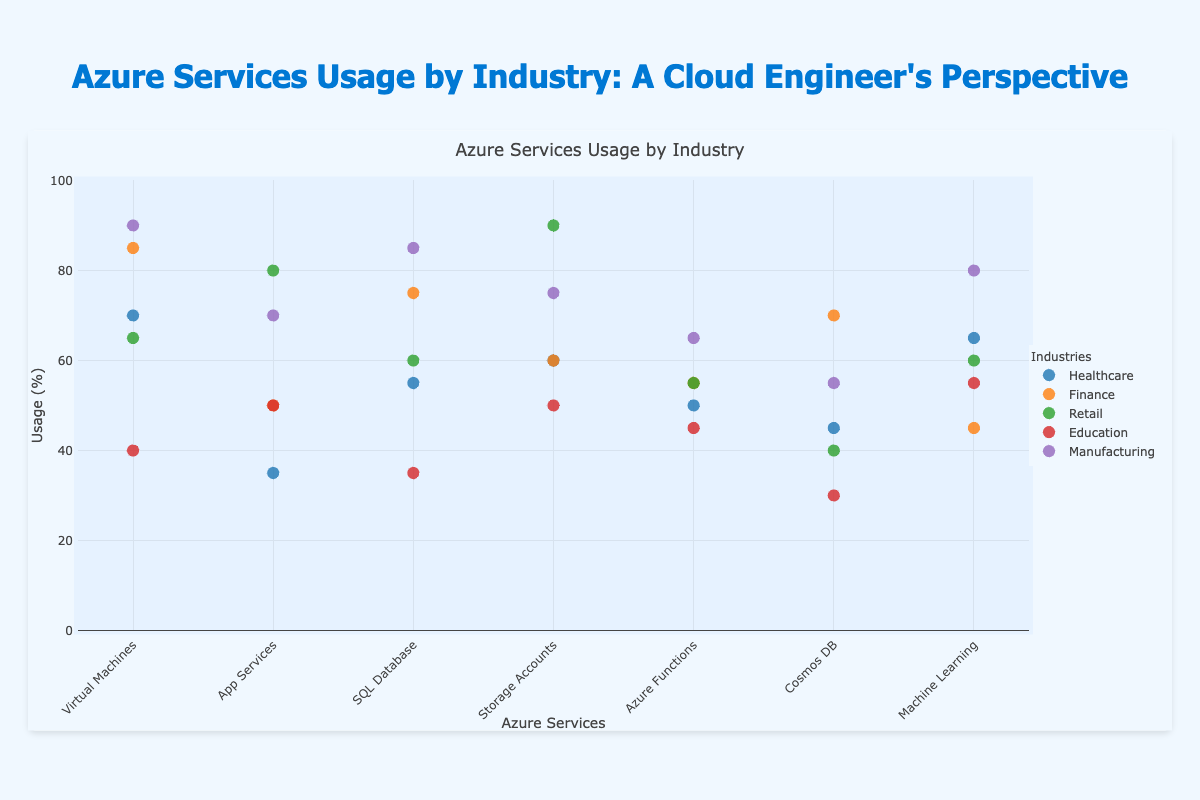How many different industries are represented in the figure? The title of the figure is "Azure Services Usage by Industry," and the legend lists the different industries. By counting each unique industry name in the legend, we find five industries: Healthcare, Finance, Retail, Education, and Manufacturing.
Answer: 5 Which industry has the highest usage of Virtual Machines? To find the industry with the highest usage of "Virtual Machines," look at the data points for the "Virtual Machines" service and identify the highest y-value. The data point with the highest y-value has a value of 90, corresponding to the Manufacturing industry.
Answer: Manufacturing On average, how much do all industries use Machine Learning? To calculate the average usage of Machine Learning across all industries, sum the usage values for Machine Learning (65, 45, 60, 55, 80) and divide by the number of industries (5). The sum is 305 and dividing by 5 gives 61.
Answer: 61 What is the difference in SQL Database usage between Finance and Healthcare? Look at the y-values for SQL Database usage for Finance and Healthcare. Finance has a usage of 75, and Healthcare has a usage of 55. Subtracting 55 from 75 gives the difference, which is 20.
Answer: 20 Which Azure service has the lowest usage in the Education industry? Look at the data points for the Education industry. Identify the service with the lowest y-value. The lowest y-value is for Cosmos DB with a usage of 30.
Answer: Cosmos DB Which two industries have the highest usage of Storage Accounts, and how do their usage values compare? Identify the data points for Storage Accounts from each industry and find the top two values. Retail (90) and Manufacturing (75) have the highest values. Comparing these values, Retail has a usage of 90, which is higher than Manufacturing's 75.
Answer: Retail and Manufacturing; Retail > Manufacturing Is there any industry that has a consistent usage above 50% for all Azure services? Check each industry's usage values across all services and see if any industry has no value below 50. Upon reviewing, Manufacturing is the only industry with all usage values (90, 70, 85, 75, 65, 55, 80) above 50.
Answer: Manufacturing How does the usage of Azure Functions in Finance compare to its usage in Education? Look at the y-values for Azure Functions usage in Finance (55) and Education (45). Finance's usage (55) is higher than Education's usage (45).
Answer: Higher in Finance 